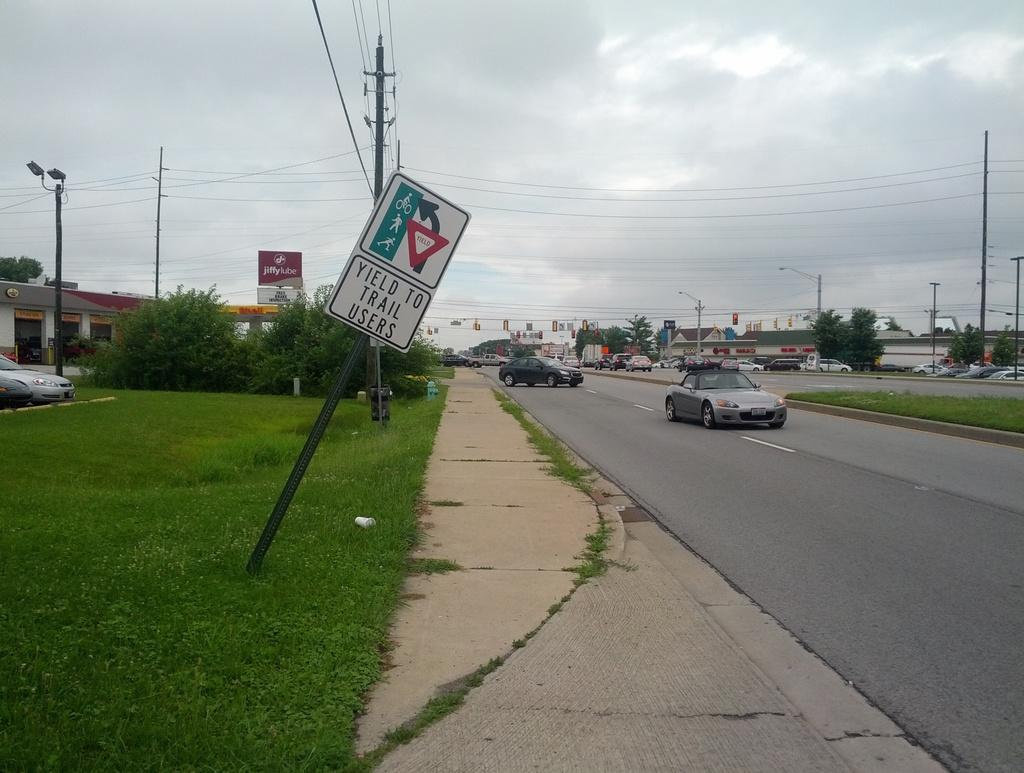<image>
Present a compact description of the photo's key features. A sign that says Yield To Trail Users is tilted next to a road. 